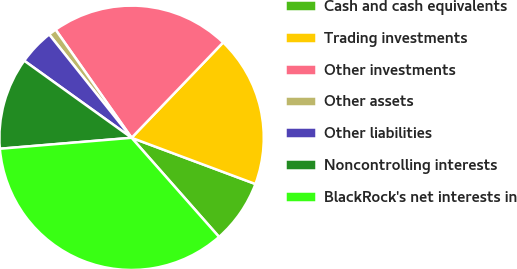Convert chart to OTSL. <chart><loc_0><loc_0><loc_500><loc_500><pie_chart><fcel>Cash and cash equivalents<fcel>Trading investments<fcel>Other investments<fcel>Other assets<fcel>Other liabilities<fcel>Noncontrolling interests<fcel>BlackRock's net interests in<nl><fcel>7.81%<fcel>18.51%<fcel>21.93%<fcel>0.96%<fcel>4.38%<fcel>11.23%<fcel>35.19%<nl></chart> 